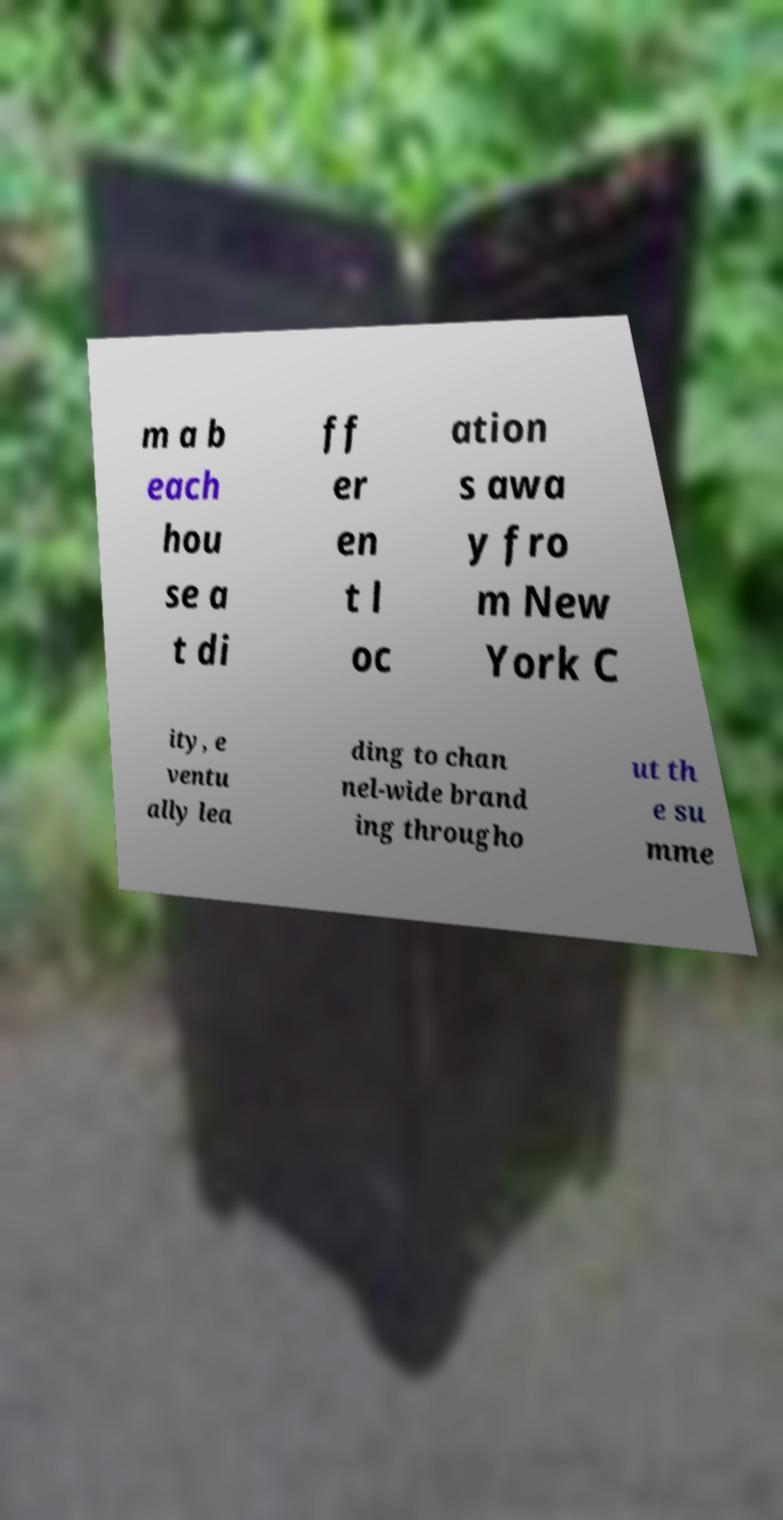Can you read and provide the text displayed in the image?This photo seems to have some interesting text. Can you extract and type it out for me? m a b each hou se a t di ff er en t l oc ation s awa y fro m New York C ity, e ventu ally lea ding to chan nel-wide brand ing througho ut th e su mme 